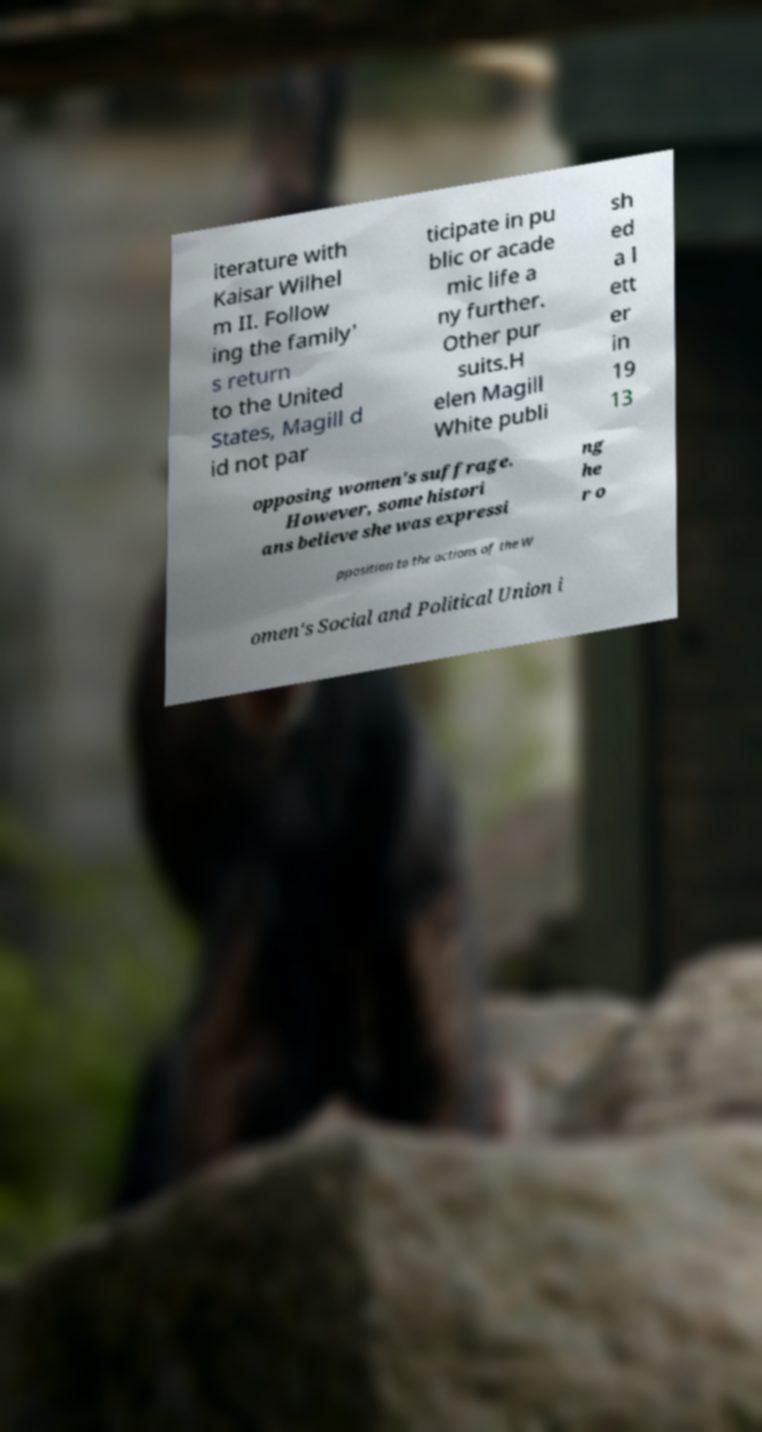I need the written content from this picture converted into text. Can you do that? iterature with Kaisar Wilhel m II. Follow ing the family' s return to the United States, Magill d id not par ticipate in pu blic or acade mic life a ny further. Other pur suits.H elen Magill White publi sh ed a l ett er in 19 13 opposing women's suffrage. However, some histori ans believe she was expressi ng he r o pposition to the actions of the W omen's Social and Political Union i 